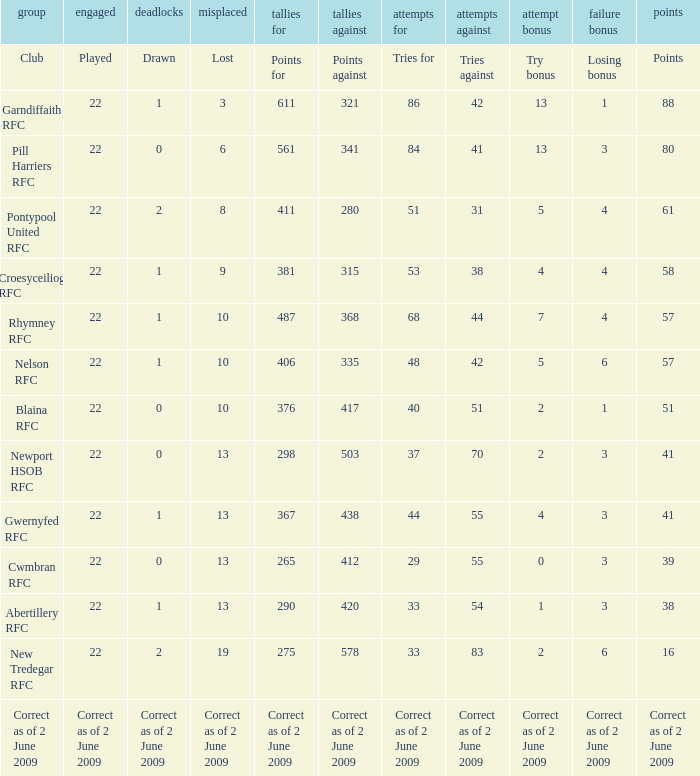Which club has 40 tries for? Blaina RFC. Could you parse the entire table? {'header': ['group', 'engaged', 'deadlocks', 'misplaced', 'tallies for', 'tallies against', 'attempts for', 'attempts against', 'attempt bonus', 'failure bonus', 'points'], 'rows': [['Club', 'Played', 'Drawn', 'Lost', 'Points for', 'Points against', 'Tries for', 'Tries against', 'Try bonus', 'Losing bonus', 'Points'], ['Garndiffaith RFC', '22', '1', '3', '611', '321', '86', '42', '13', '1', '88'], ['Pill Harriers RFC', '22', '0', '6', '561', '341', '84', '41', '13', '3', '80'], ['Pontypool United RFC', '22', '2', '8', '411', '280', '51', '31', '5', '4', '61'], ['Croesyceiliog RFC', '22', '1', '9', '381', '315', '53', '38', '4', '4', '58'], ['Rhymney RFC', '22', '1', '10', '487', '368', '68', '44', '7', '4', '57'], ['Nelson RFC', '22', '1', '10', '406', '335', '48', '42', '5', '6', '57'], ['Blaina RFC', '22', '0', '10', '376', '417', '40', '51', '2', '1', '51'], ['Newport HSOB RFC', '22', '0', '13', '298', '503', '37', '70', '2', '3', '41'], ['Gwernyfed RFC', '22', '1', '13', '367', '438', '44', '55', '4', '3', '41'], ['Cwmbran RFC', '22', '0', '13', '265', '412', '29', '55', '0', '3', '39'], ['Abertillery RFC', '22', '1', '13', '290', '420', '33', '54', '1', '3', '38'], ['New Tredegar RFC', '22', '2', '19', '275', '578', '33', '83', '2', '6', '16'], ['Correct as of 2 June 2009', 'Correct as of 2 June 2009', 'Correct as of 2 June 2009', 'Correct as of 2 June 2009', 'Correct as of 2 June 2009', 'Correct as of 2 June 2009', 'Correct as of 2 June 2009', 'Correct as of 2 June 2009', 'Correct as of 2 June 2009', 'Correct as of 2 June 2009', 'Correct as of 2 June 2009']]} 